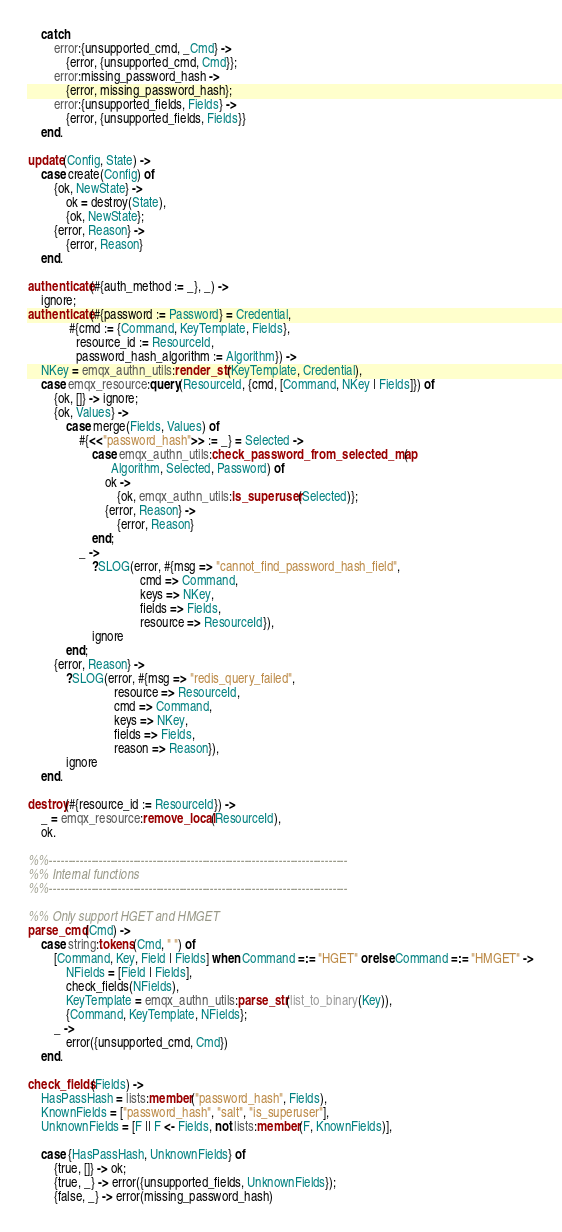Convert code to text. <code><loc_0><loc_0><loc_500><loc_500><_Erlang_>    catch
        error:{unsupported_cmd, _Cmd} ->
            {error, {unsupported_cmd, Cmd}};
        error:missing_password_hash ->
            {error, missing_password_hash};
        error:{unsupported_fields, Fields} ->
            {error, {unsupported_fields, Fields}}
    end.

update(Config, State) ->
    case create(Config) of
        {ok, NewState} ->
            ok = destroy(State),
            {ok, NewState};
        {error, Reason} ->
            {error, Reason}
    end.

authenticate(#{auth_method := _}, _) ->
    ignore;
authenticate(#{password := Password} = Credential,
             #{cmd := {Command, KeyTemplate, Fields},
               resource_id := ResourceId,
               password_hash_algorithm := Algorithm}) ->
    NKey = emqx_authn_utils:render_str(KeyTemplate, Credential),
    case emqx_resource:query(ResourceId, {cmd, [Command, NKey | Fields]}) of
        {ok, []} -> ignore;
        {ok, Values} ->
            case merge(Fields, Values) of
                #{<<"password_hash">> := _} = Selected ->
                    case emqx_authn_utils:check_password_from_selected_map(
                          Algorithm, Selected, Password) of
                        ok ->
                            {ok, emqx_authn_utils:is_superuser(Selected)};
                        {error, Reason} ->
                            {error, Reason}
                    end;
                _ ->
                    ?SLOG(error, #{msg => "cannot_find_password_hash_field",
                                   cmd => Command,
                                   keys => NKey,
                                   fields => Fields,
                                   resource => ResourceId}),
                    ignore
            end;
        {error, Reason} ->
            ?SLOG(error, #{msg => "redis_query_failed",
                           resource => ResourceId,
                           cmd => Command,
                           keys => NKey,
                           fields => Fields,
                           reason => Reason}),
            ignore
    end.

destroy(#{resource_id := ResourceId}) ->
    _ = emqx_resource:remove_local(ResourceId),
    ok.

%%------------------------------------------------------------------------------
%% Internal functions
%%------------------------------------------------------------------------------

%% Only support HGET and HMGET
parse_cmd(Cmd) ->
    case string:tokens(Cmd, " ") of
        [Command, Key, Field | Fields] when Command =:= "HGET" orelse Command =:= "HMGET" ->
            NFields = [Field | Fields],
            check_fields(NFields),
            KeyTemplate = emqx_authn_utils:parse_str(list_to_binary(Key)),
            {Command, KeyTemplate, NFields};
        _ ->
            error({unsupported_cmd, Cmd})
    end.

check_fields(Fields) ->
    HasPassHash = lists:member("password_hash", Fields),
    KnownFields = ["password_hash", "salt", "is_superuser"],
    UnknownFields = [F || F <- Fields, not lists:member(F, KnownFields)],

    case {HasPassHash, UnknownFields} of
        {true, []} -> ok;
        {true, _} -> error({unsupported_fields, UnknownFields});
        {false, _} -> error(missing_password_hash)</code> 